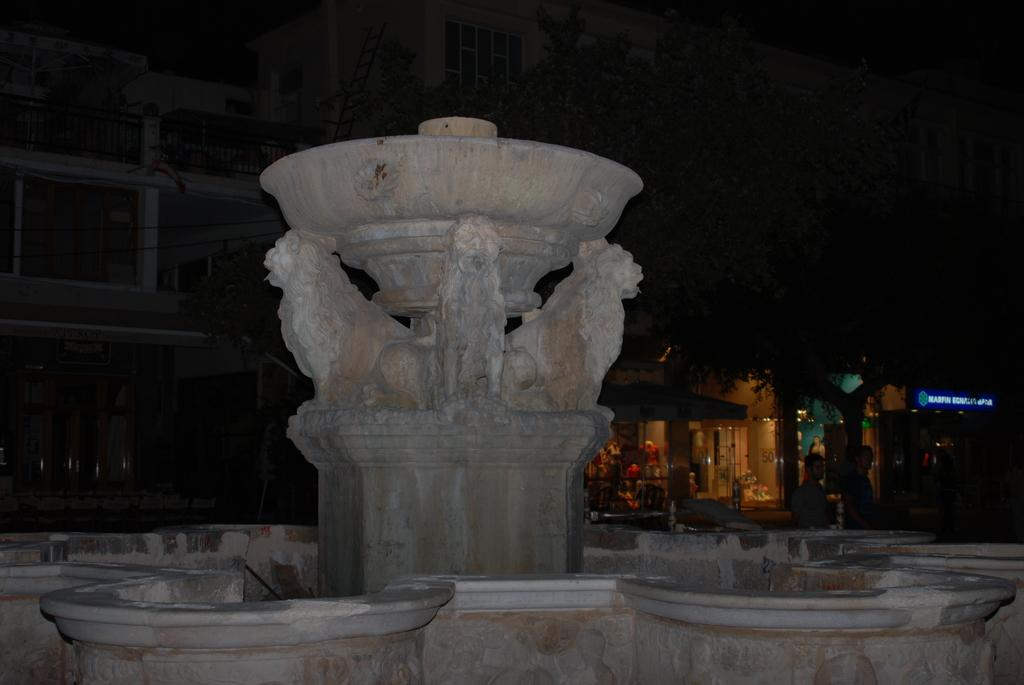What is the main subject of the image? The main subjects of the image are statues, which can be found on a platform and a wall. Can you describe the background of the image? The background of the image is dark, and there is a building, people, a tree, a board, and other objects visible. What type of objects are present on the platform and wall? The objects on the platform and wall are statues. What type of soup is being served at the feast in the image? There is no feast or soup present in the image; it features statues on a platform and a wall with a dark background. Can you tell me how many owls are perched on the statues in the image? There are no owls present in the image; it features statues on a platform and a wall with a dark background. 